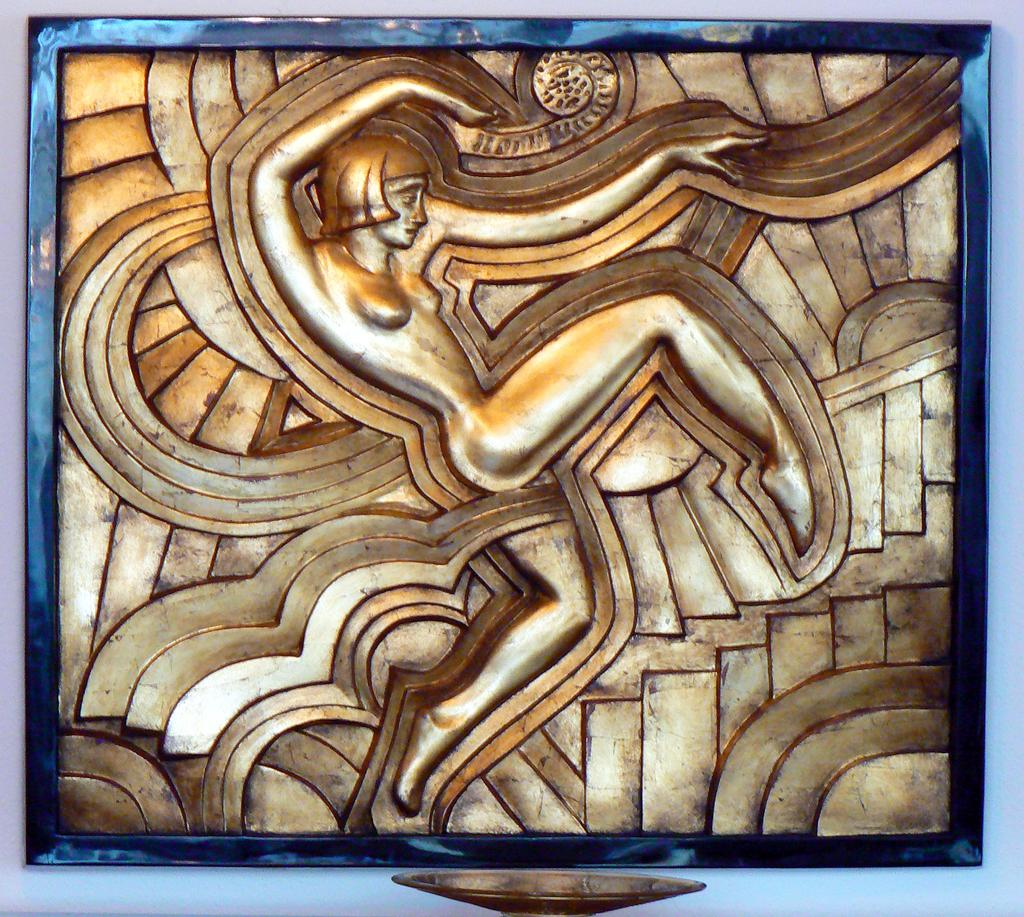What object can be seen in the image that typically holds a photograph? There is a photo frame in the image. Where is the photo frame located? The photo frame is placed on a wall. What type of artwork is present in the image? There is a woman's sculpture in the image. What is the color of the sculpture? The sculpture is in golden color. What type of toys can be seen in the image? There are no toys present in the image. What is the stem of the sculpture made of? There is no stem mentioned in the image, as the sculpture is described as a woman's sculpture in golden color. 